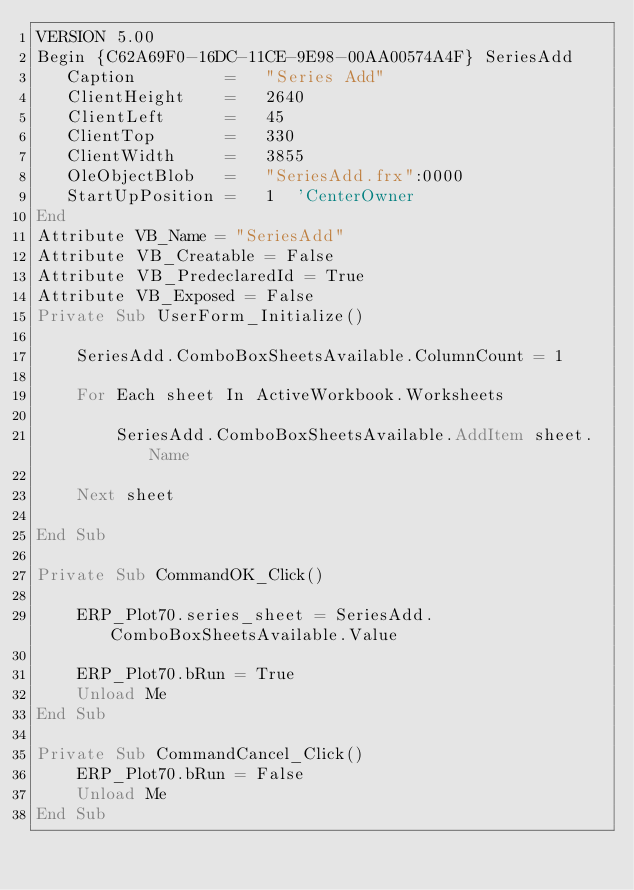<code> <loc_0><loc_0><loc_500><loc_500><_VisualBasic_>VERSION 5.00
Begin {C62A69F0-16DC-11CE-9E98-00AA00574A4F} SeriesAdd 
   Caption         =   "Series Add"
   ClientHeight    =   2640
   ClientLeft      =   45
   ClientTop       =   330
   ClientWidth     =   3855
   OleObjectBlob   =   "SeriesAdd.frx":0000
   StartUpPosition =   1  'CenterOwner
End
Attribute VB_Name = "SeriesAdd"
Attribute VB_Creatable = False
Attribute VB_PredeclaredId = True
Attribute VB_Exposed = False
Private Sub UserForm_Initialize()
    
    SeriesAdd.ComboBoxSheetsAvailable.ColumnCount = 1
    
    For Each sheet In ActiveWorkbook.Worksheets
        
        SeriesAdd.ComboBoxSheetsAvailable.AddItem sheet.Name
        
    Next sheet
    
End Sub

Private Sub CommandOK_Click()
    
    ERP_Plot70.series_sheet = SeriesAdd.ComboBoxSheetsAvailable.Value
    
    ERP_Plot70.bRun = True
    Unload Me
End Sub

Private Sub CommandCancel_Click()
    ERP_Plot70.bRun = False
    Unload Me
End Sub

</code> 